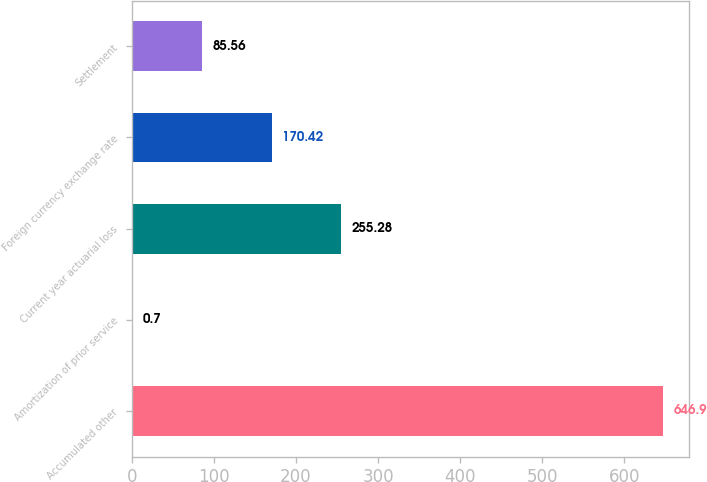Convert chart. <chart><loc_0><loc_0><loc_500><loc_500><bar_chart><fcel>Accumulated other<fcel>Amortization of prior service<fcel>Current year actuarial loss<fcel>Foreign currency exchange rate<fcel>Settlement<nl><fcel>646.9<fcel>0.7<fcel>255.28<fcel>170.42<fcel>85.56<nl></chart> 